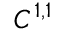<formula> <loc_0><loc_0><loc_500><loc_500>C ^ { 1 , 1 }</formula> 